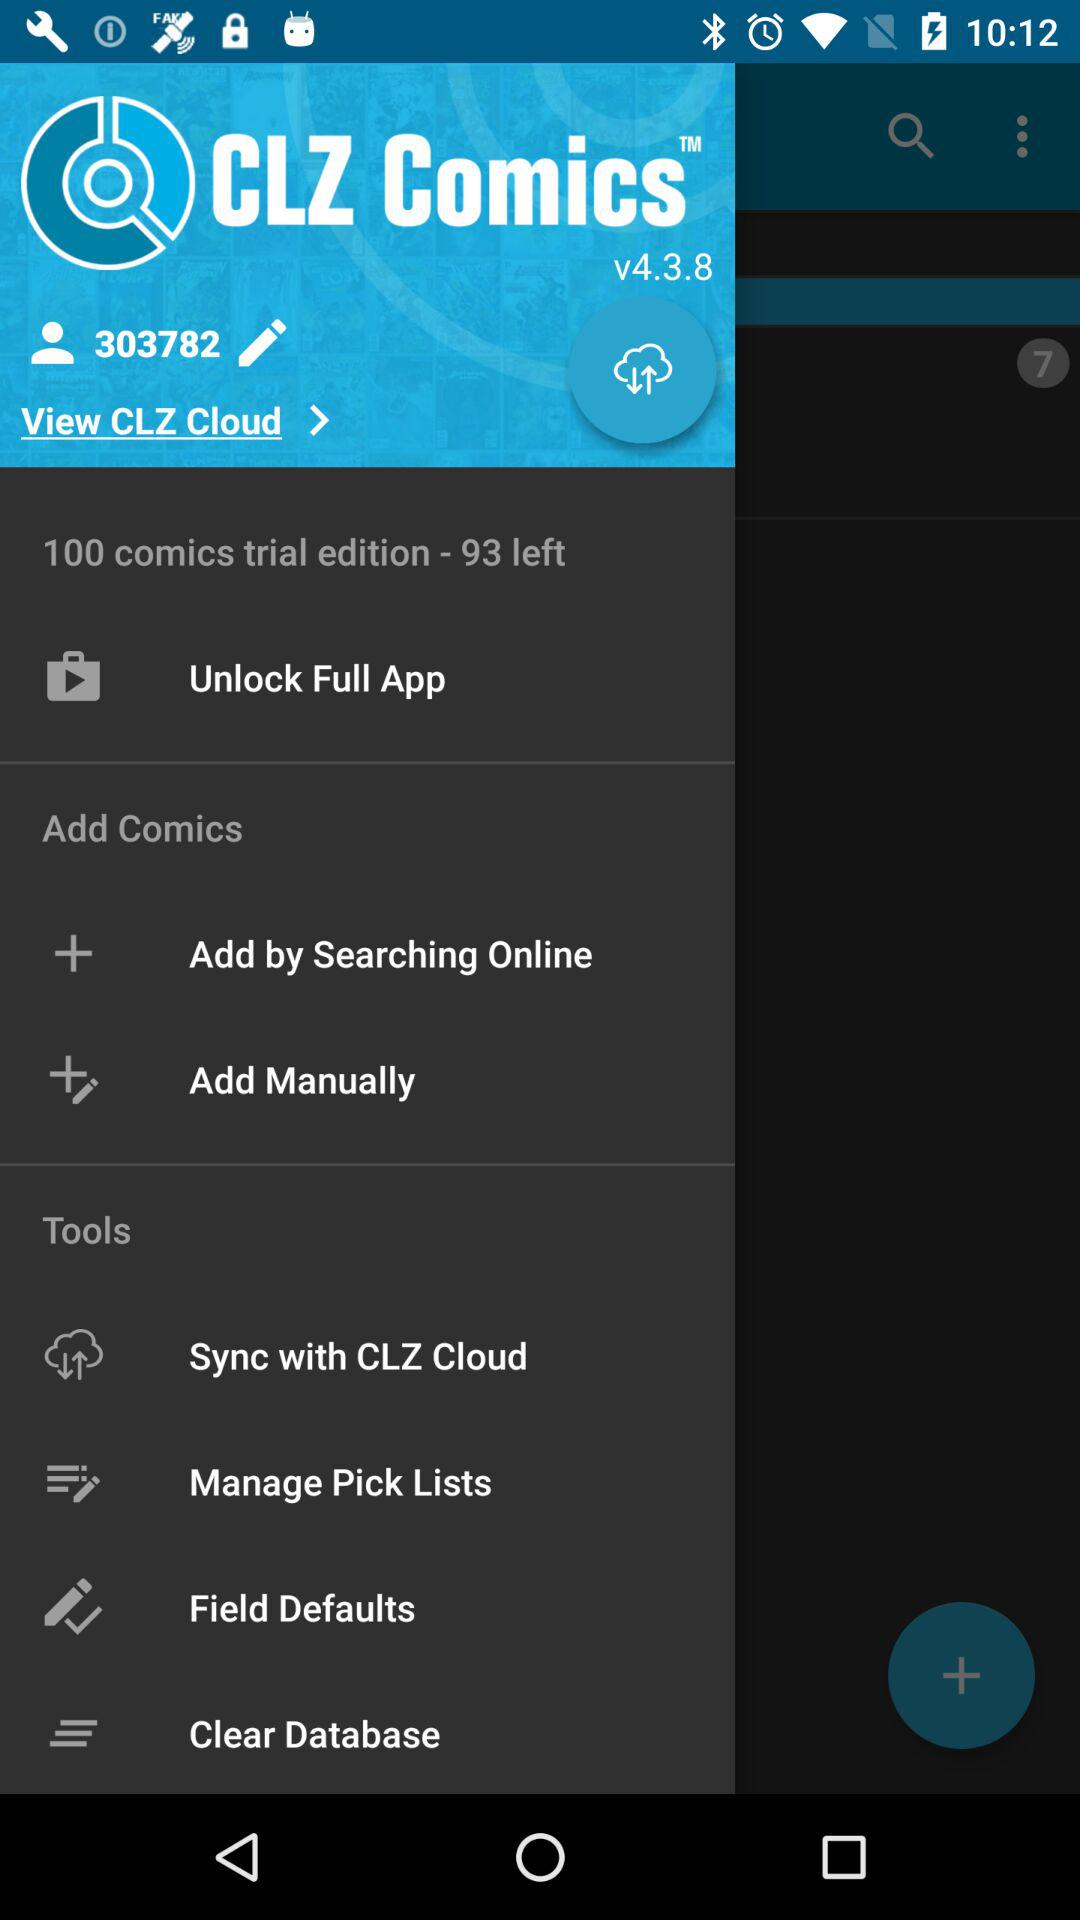What is the version of the "CLZ Comics" application? The version is v4.3.8. 